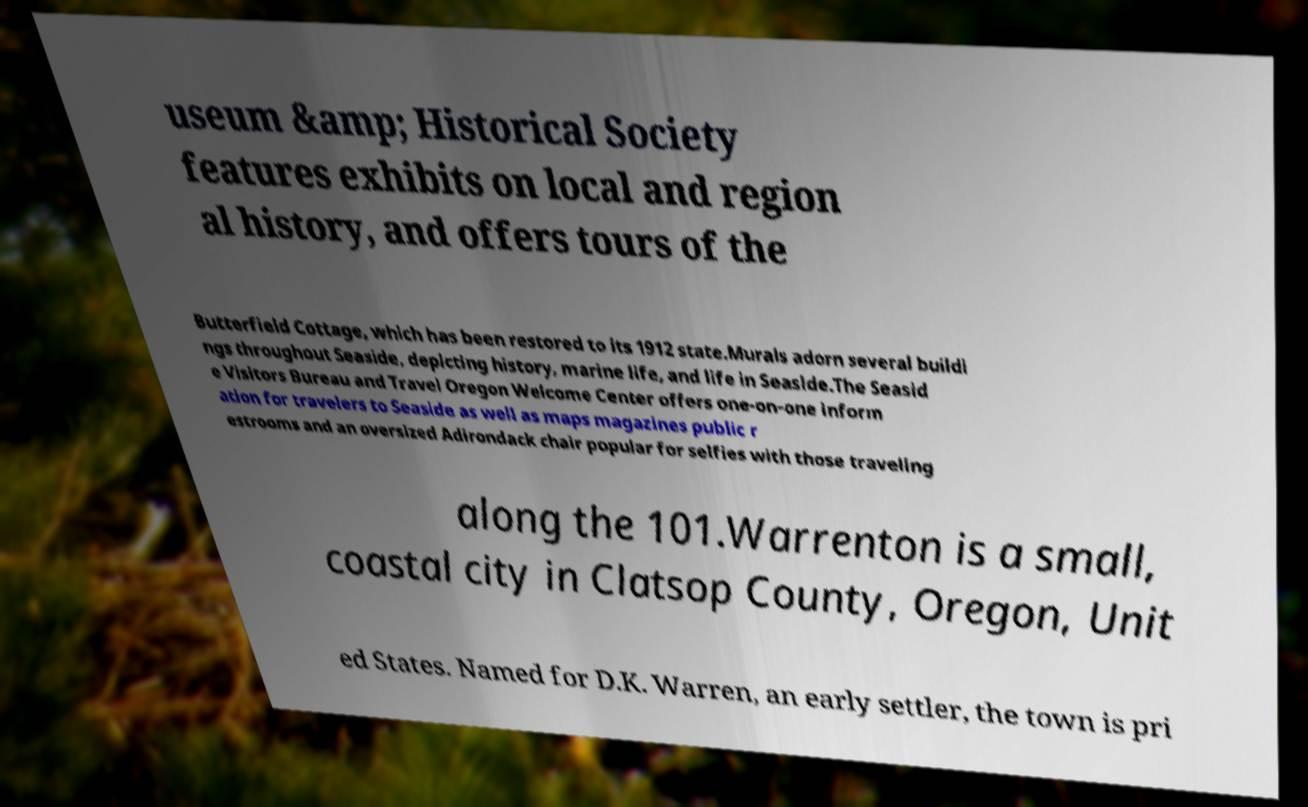For documentation purposes, I need the text within this image transcribed. Could you provide that? useum &amp; Historical Society features exhibits on local and region al history, and offers tours of the Butterfield Cottage, which has been restored to its 1912 state.Murals adorn several buildi ngs throughout Seaside, depicting history, marine life, and life in Seaside.The Seasid e Visitors Bureau and Travel Oregon Welcome Center offers one-on-one inform ation for travelers to Seaside as well as maps magazines public r estrooms and an oversized Adirondack chair popular for selfies with those traveling along the 101.Warrenton is a small, coastal city in Clatsop County, Oregon, Unit ed States. Named for D.K. Warren, an early settler, the town is pri 